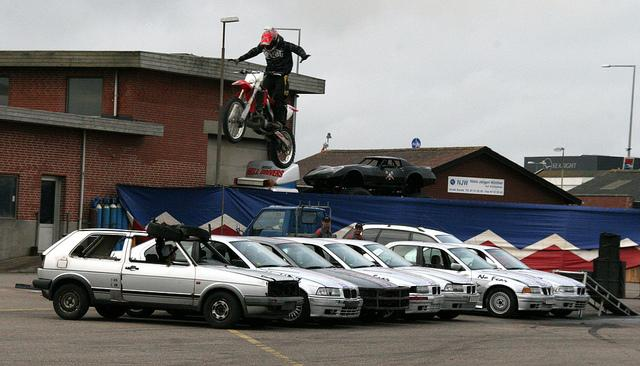Why is he in midair? jumping 